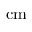<formula> <loc_0><loc_0><loc_500><loc_500>c m</formula> 